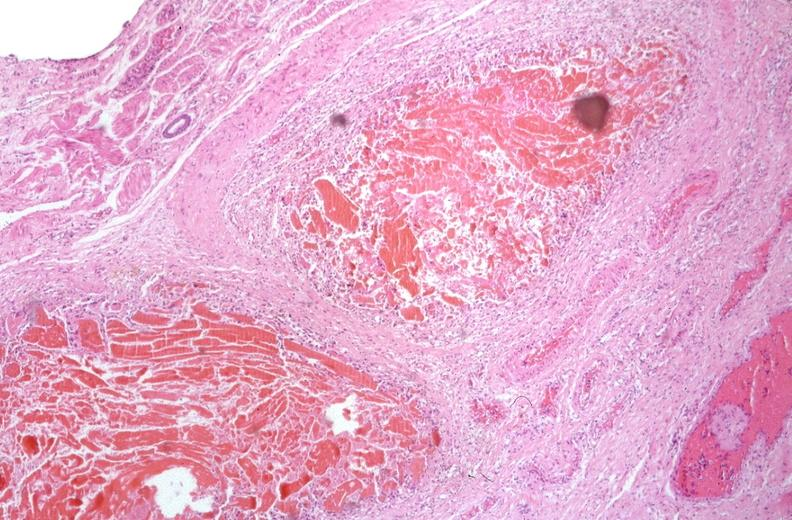s intramural one lesion present?
Answer the question using a single word or phrase. No 